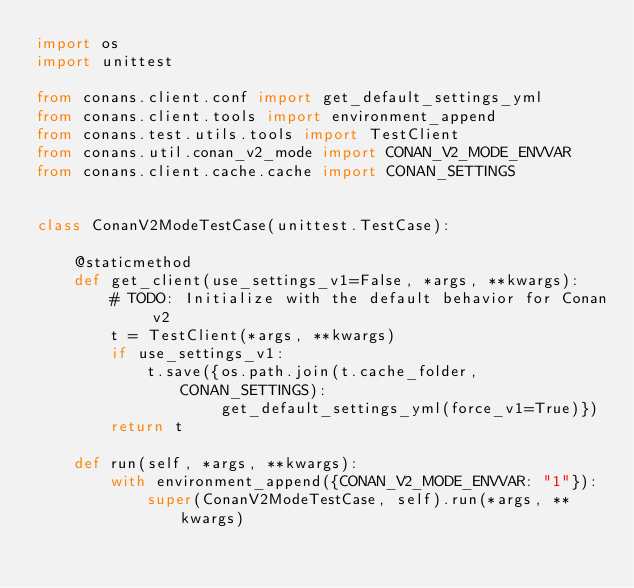<code> <loc_0><loc_0><loc_500><loc_500><_Python_>import os
import unittest

from conans.client.conf import get_default_settings_yml
from conans.client.tools import environment_append
from conans.test.utils.tools import TestClient
from conans.util.conan_v2_mode import CONAN_V2_MODE_ENVVAR
from conans.client.cache.cache import CONAN_SETTINGS


class ConanV2ModeTestCase(unittest.TestCase):

    @staticmethod
    def get_client(use_settings_v1=False, *args, **kwargs):
        # TODO: Initialize with the default behavior for Conan v2
        t = TestClient(*args, **kwargs)
        if use_settings_v1:
            t.save({os.path.join(t.cache_folder, CONAN_SETTINGS):
                    get_default_settings_yml(force_v1=True)})
        return t

    def run(self, *args, **kwargs):
        with environment_append({CONAN_V2_MODE_ENVVAR: "1"}):
            super(ConanV2ModeTestCase, self).run(*args, **kwargs)
</code> 